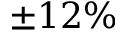<formula> <loc_0><loc_0><loc_500><loc_500>\pm 1 2 \%</formula> 